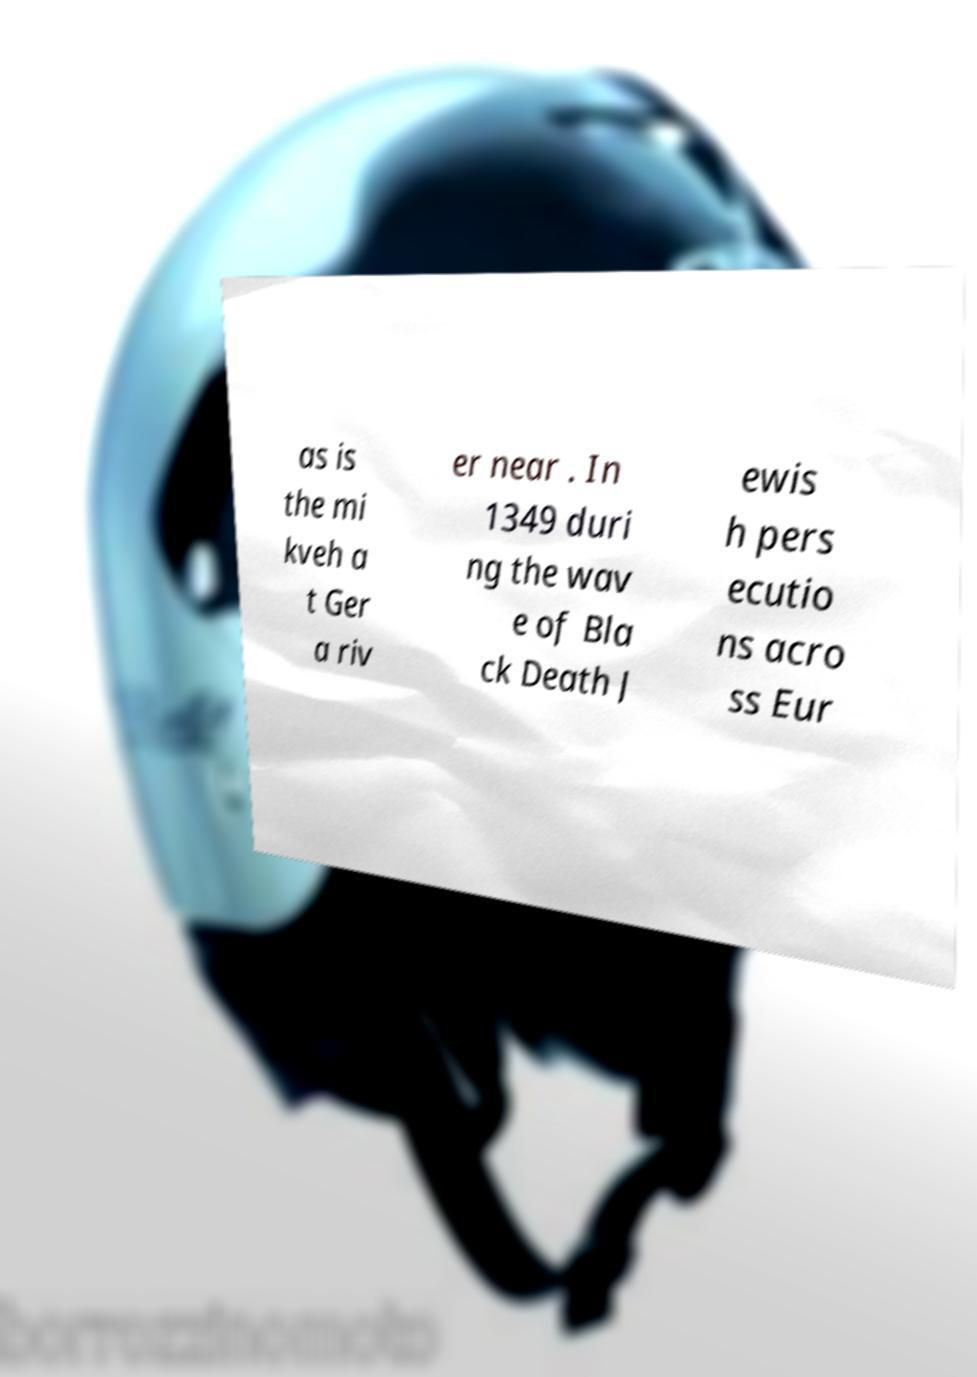I need the written content from this picture converted into text. Can you do that? as is the mi kveh a t Ger a riv er near . In 1349 duri ng the wav e of Bla ck Death J ewis h pers ecutio ns acro ss Eur 